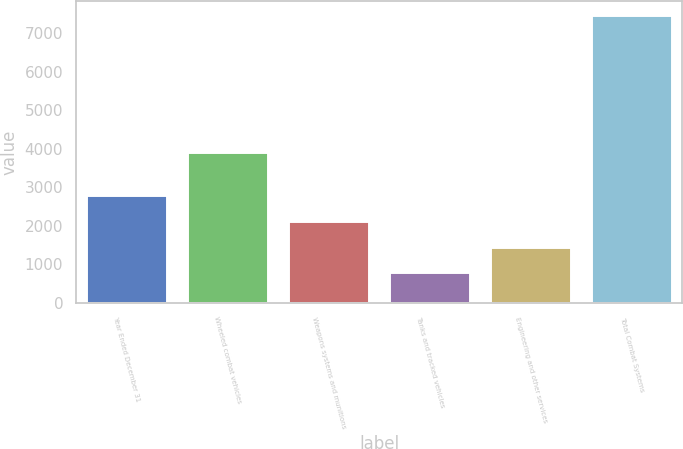Convert chart to OTSL. <chart><loc_0><loc_0><loc_500><loc_500><bar_chart><fcel>Year Ended December 31<fcel>Wheeled combat vehicles<fcel>Weapons systems and munitions<fcel>Tanks and tracked vehicles<fcel>Engineering and other services<fcel>Total Combat Systems<nl><fcel>2795.7<fcel>3930<fcel>2127.8<fcel>792<fcel>1459.9<fcel>7471<nl></chart> 